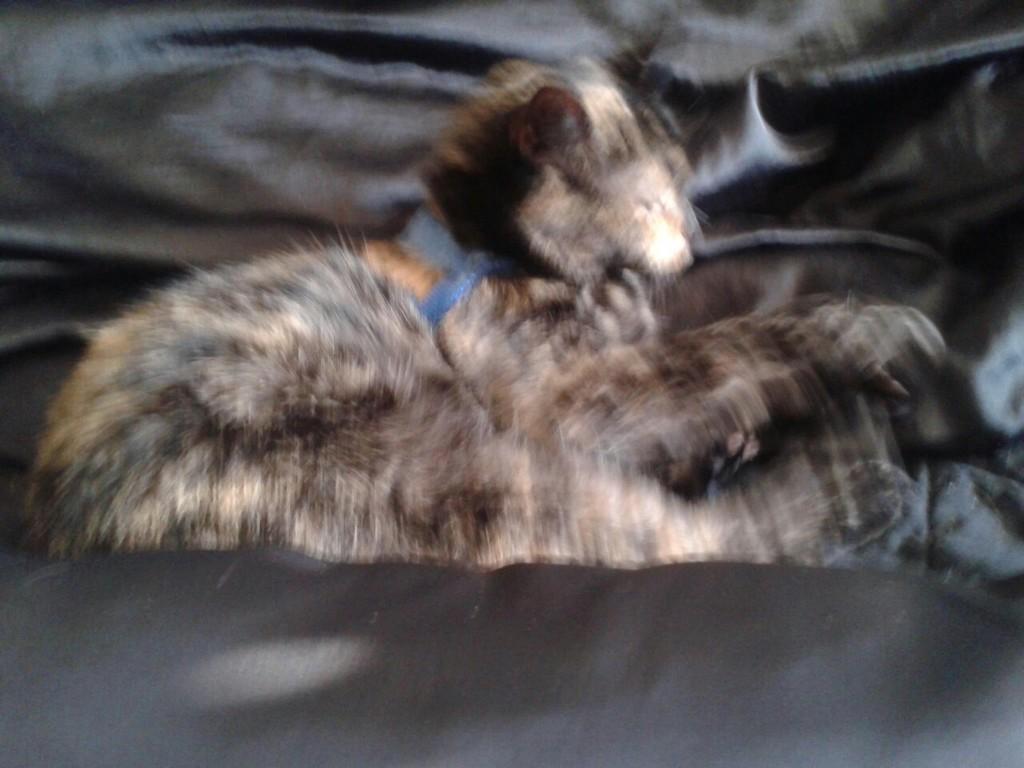In one or two sentences, can you explain what this image depicts? In the image we can see an animal and the whole image is blurred. 